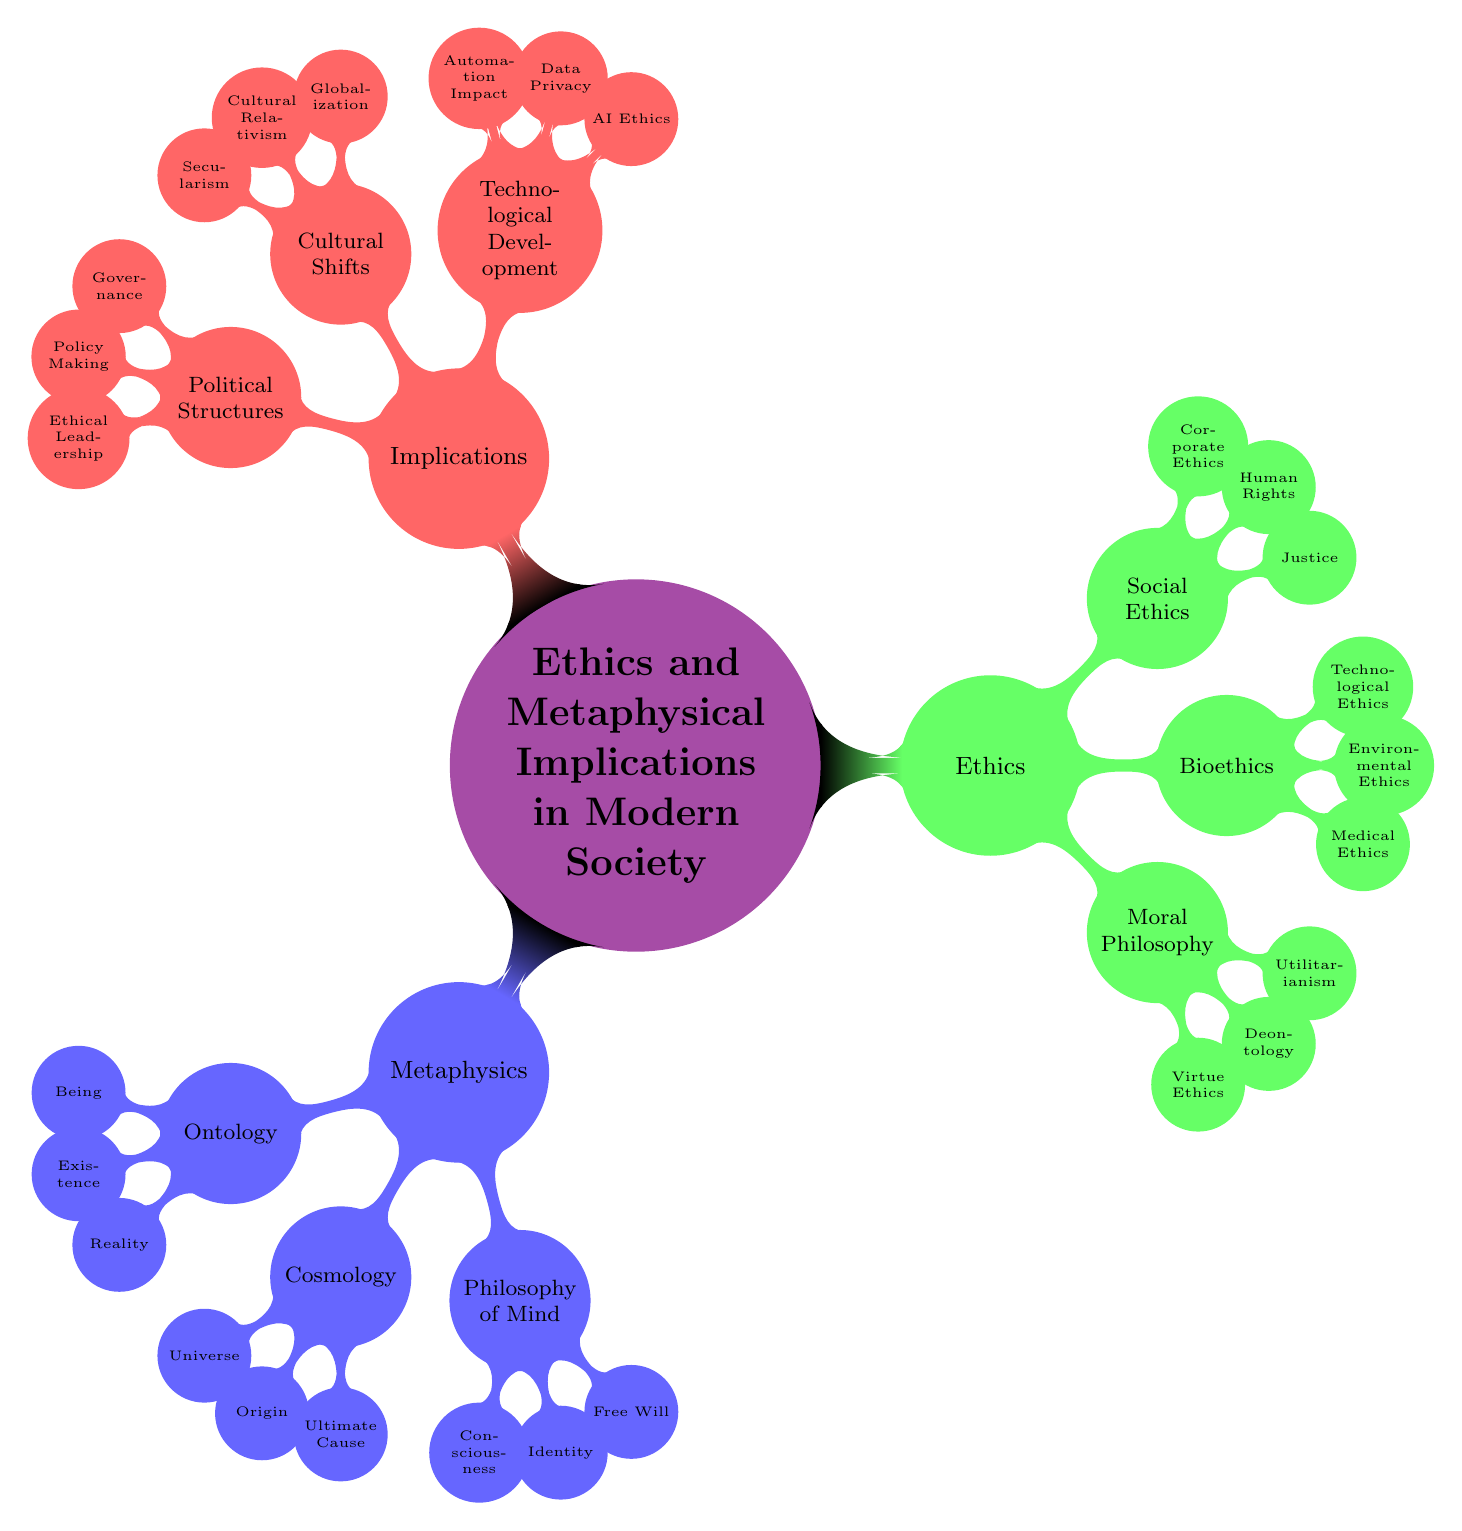What is the main topic of this mind map? The main topic, as indicated at the center of the mind map, is "Ethics and Metaphysical Implications in Modern Society."
Answer: Ethics and Metaphysical Implications in Modern Society How many subtopics are under "Metaphysics"? Under the "Metaphysics" node, there are three subtopics: Ontology, Cosmology, and Philosophy of Mind.
Answer: 3 What are the three elements related to "Bioethics"? The elements under "Bioethics" include Medical Ethics, Environmental Ethics, and Technological Ethics, as shown in the branches.
Answer: Medical Ethics, Environmental Ethics, Technological Ethics Which subtopic includes "Free Will"? "Free Will" is an element under the subtopic "Philosophy of Mind," demonstrating its connection to metaphysical aspects of consciousness and identity.
Answer: Philosophy of Mind What ethical approach emphasizes the outcomes of actions? The ethical approach that focuses on the outcomes or consequences of actions is Utilitarianism, which is part of moral philosophy in the ethics section.
Answer: Utilitarianism How many elements are listed under "Technological Development"? There are three elements listed under "Technological Development," which are AI Ethics, Data Privacy, and Automation Impact.
Answer: 3 What is the relationship between "Cultural Shifts" and "Secularism"? "Secularism" is one of the elements that fall under the subtopic "Cultural Shifts," reflecting how changing cultural values affect metaphysical and ethical discussions.
Answer: Cultural Shifts Which concept addresses the responsibility companies have in ethical practices? Corporate Ethics addresses the responsibility that companies have regarding ethical practices within the realm of Social Ethics as indicated in the diagram.
Answer: Corporate Ethics What does the subtopic "Governance" fall under? "Governance" is categorized under the subtopic "Political Structures," indicating its relevance to the implications of ethics in governance and policy-making processes.
Answer: Political Structures 